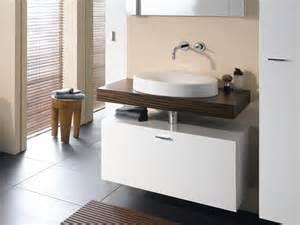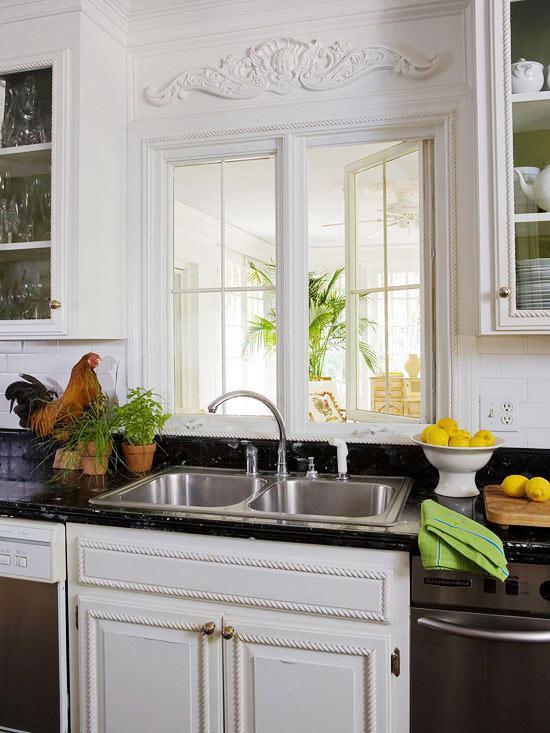The first image is the image on the left, the second image is the image on the right. Examine the images to the left and right. Is the description "An image shows a stainless steel, double basin sink with plants nearby." accurate? Answer yes or no. Yes. 